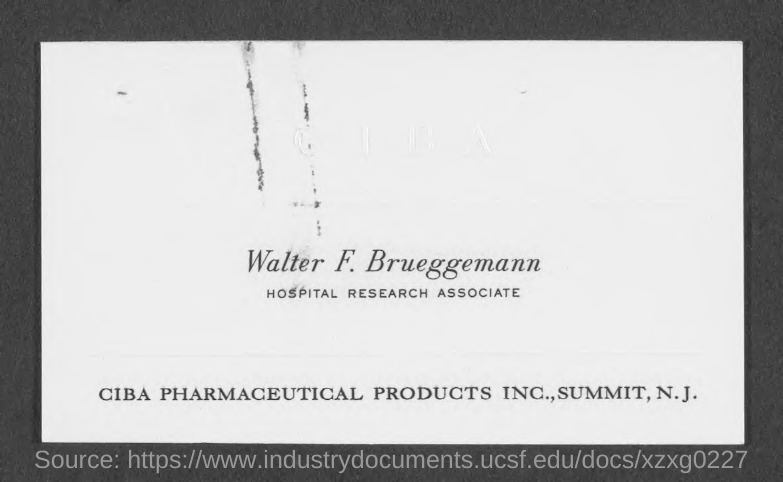Highlight a few significant elements in this photo. Walter F. Brueggemann is a Hospital Research Associate. Walter F. Brueggemann is a Hospital Research Associate. 